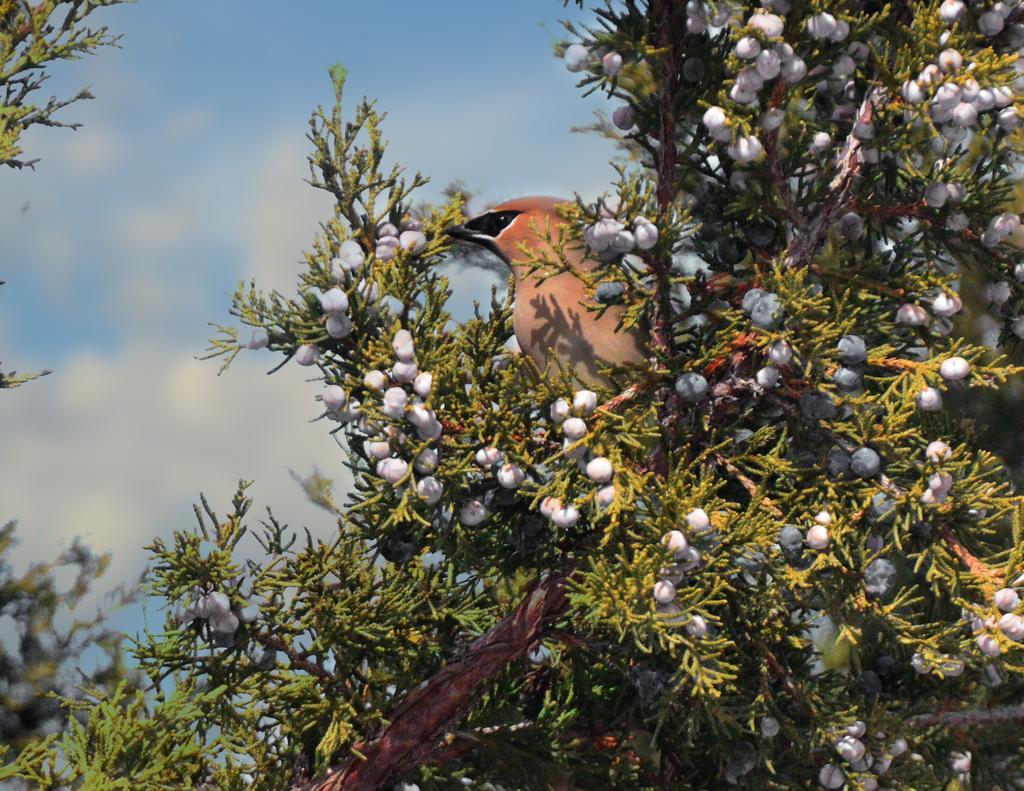Describe this image in one or two sentences. In this image in the front there are plants and on the plants there is a bird standing and the background is blurry and the sky is cloudy and there are cottons on the plants. 